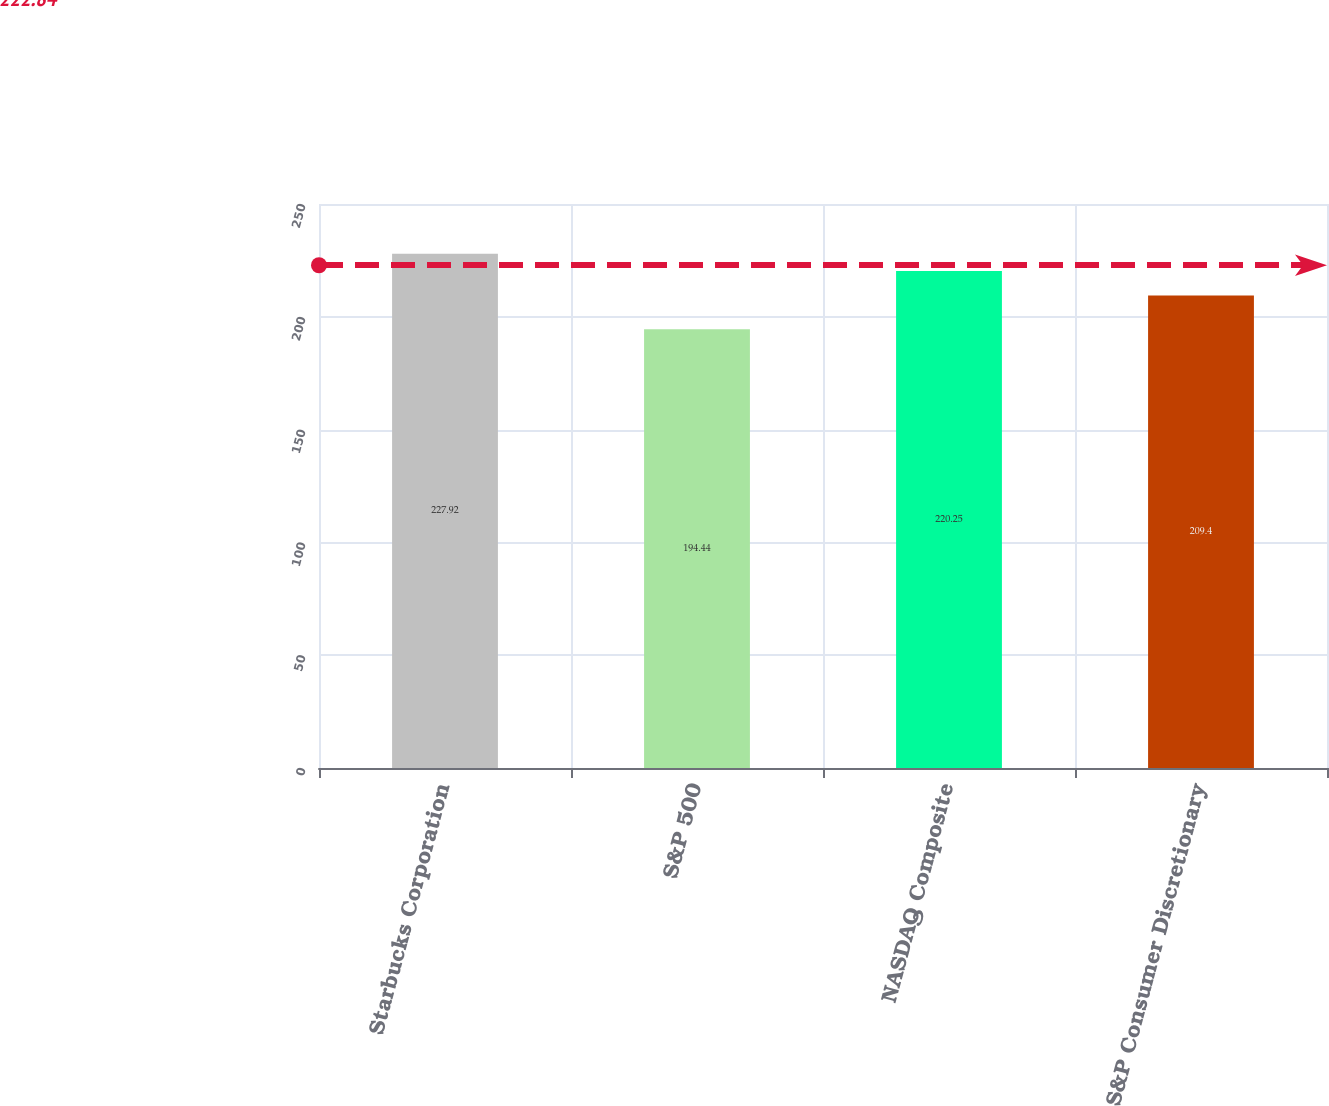<chart> <loc_0><loc_0><loc_500><loc_500><bar_chart><fcel>Starbucks Corporation<fcel>S&P 500<fcel>NASDAQ Composite<fcel>S&P Consumer Discretionary<nl><fcel>227.92<fcel>194.44<fcel>220.25<fcel>209.4<nl></chart> 